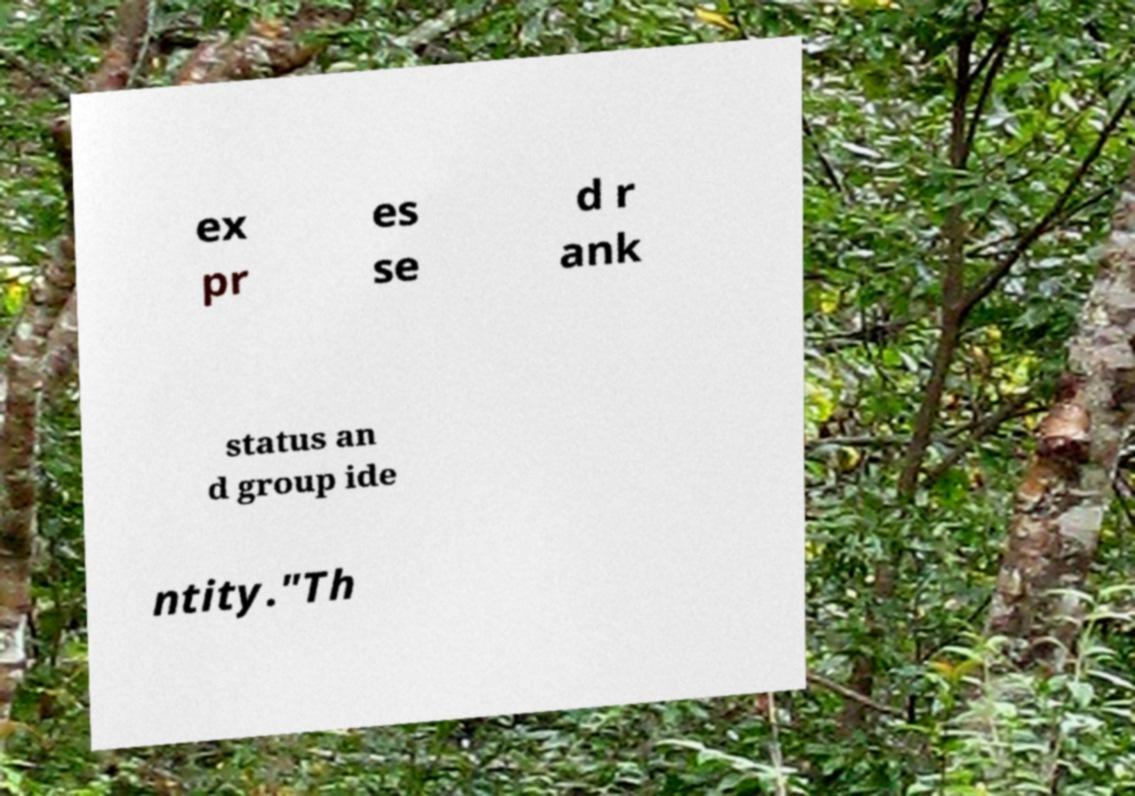Please identify and transcribe the text found in this image. ex pr es se d r ank status an d group ide ntity."Th 